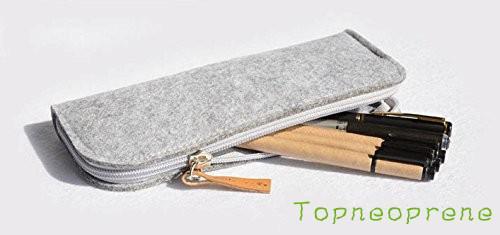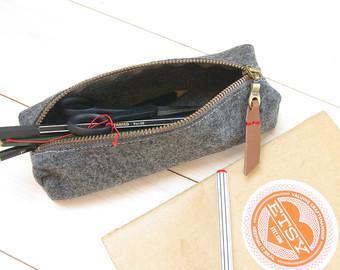The first image is the image on the left, the second image is the image on the right. Assess this claim about the two images: "The left image contains a gray tube-shaped zipper case to the left of a green one, and the right image includes gray, green and orange closed tube-shaped cases.". Correct or not? Answer yes or no. No. The first image is the image on the left, the second image is the image on the right. Assess this claim about the two images: "There are five or more felt pencil cases.". Correct or not? Answer yes or no. No. 